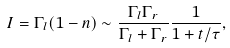<formula> <loc_0><loc_0><loc_500><loc_500>I = \Gamma _ { l } ( 1 - n ) \sim \frac { \Gamma _ { l } \Gamma _ { r } } { \Gamma _ { l } + \Gamma _ { r } } \frac { 1 } { 1 + t / \tau } ,</formula> 